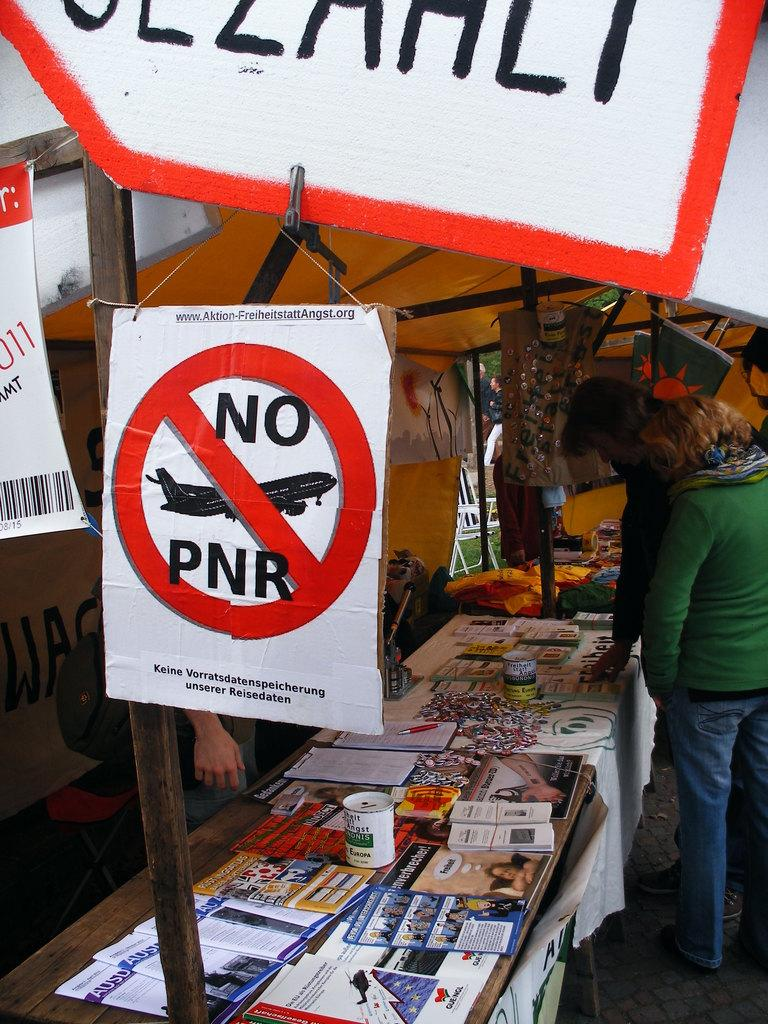<image>
Relay a brief, clear account of the picture shown. A cardboard sign shows an airplane and the words "NO PNR". 